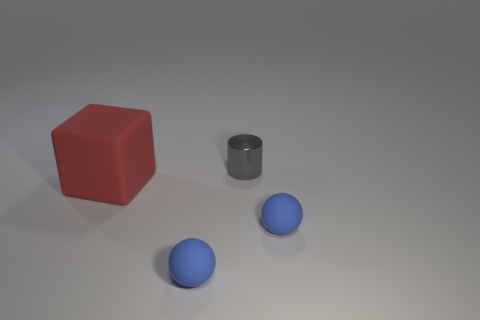Subtract all blue balls. How many were subtracted if there are1blue balls left? 1 Add 2 tiny gray shiny cylinders. How many objects exist? 6 Subtract all blocks. Subtract all tiny metallic cylinders. How many objects are left? 2 Add 1 blue rubber spheres. How many blue rubber spheres are left? 3 Add 1 gray things. How many gray things exist? 2 Subtract 1 red blocks. How many objects are left? 3 